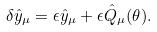<formula> <loc_0><loc_0><loc_500><loc_500>\delta \hat { y } _ { \mu } = \epsilon \hat { y } _ { \mu } + \epsilon \hat { Q } _ { \mu } ( \theta ) .</formula> 